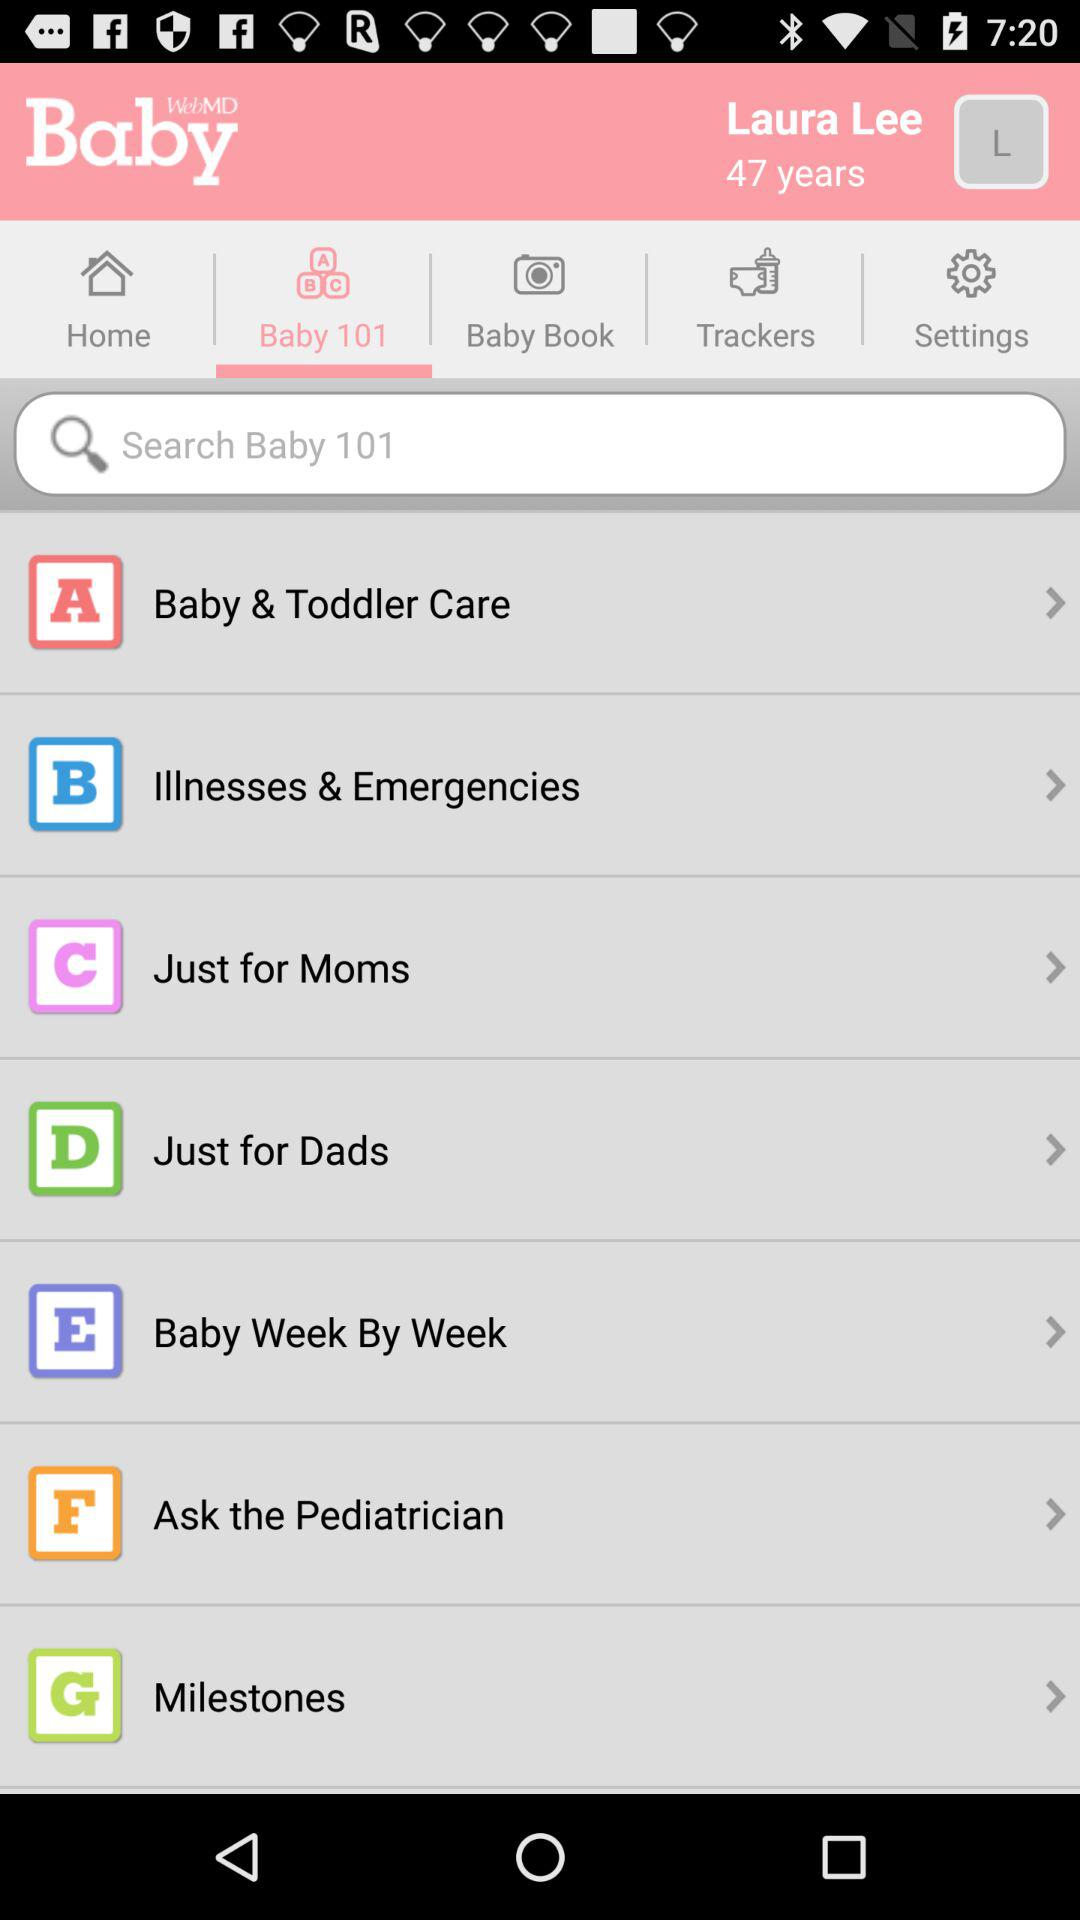How old is the baby?
When the provided information is insufficient, respond with <no answer>. <no answer> 